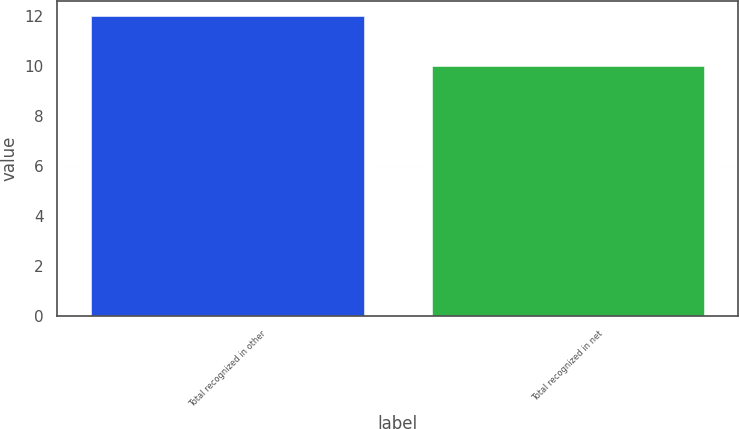<chart> <loc_0><loc_0><loc_500><loc_500><bar_chart><fcel>Total recognized in other<fcel>Total recognized in net<nl><fcel>12<fcel>10<nl></chart> 